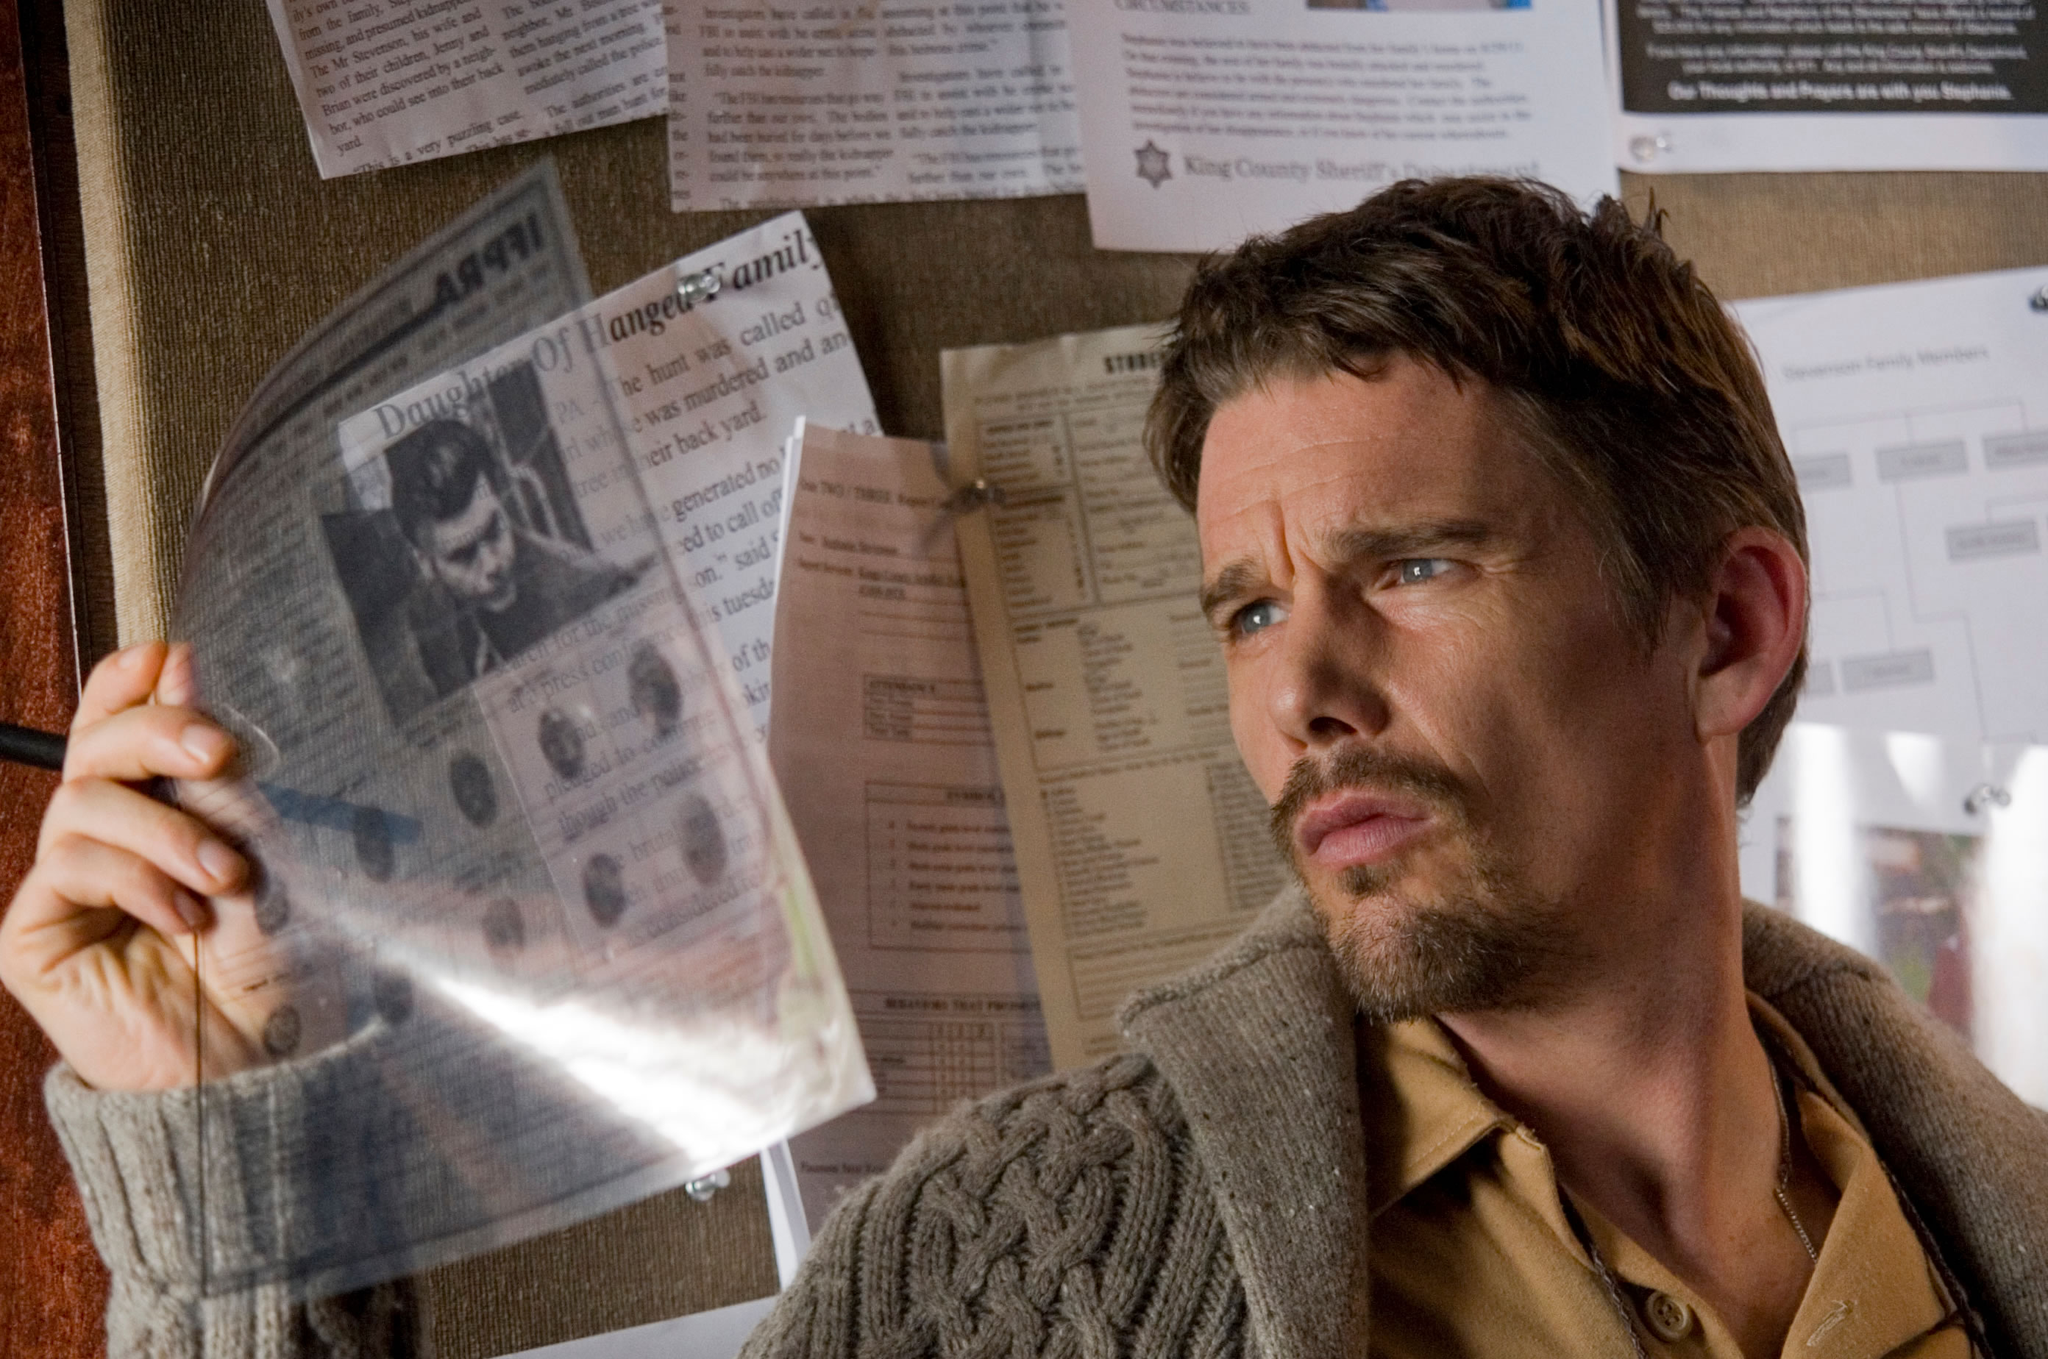Can you describe the items on the bulletin board behind him? The bulletin board behind the man is cluttered with a variety of papers including newspaper articles, photographs, and notes. These items likely serve as crucial pieces of evidence or clues in the investigation. Some papers have visible text, highlighting names and dates, while others feature images that might be related to the case he is investigating. Do any items on the board seem particularly significant? One notable item is a prominent newspaper clipping that the man holds. It seems to capture his attention significantly, suggesting it holds key information, perhaps a breakthrough in his investigation. Other noticeable items include a map and various marked photographs, which likely outline connections or track movements related to the case. 